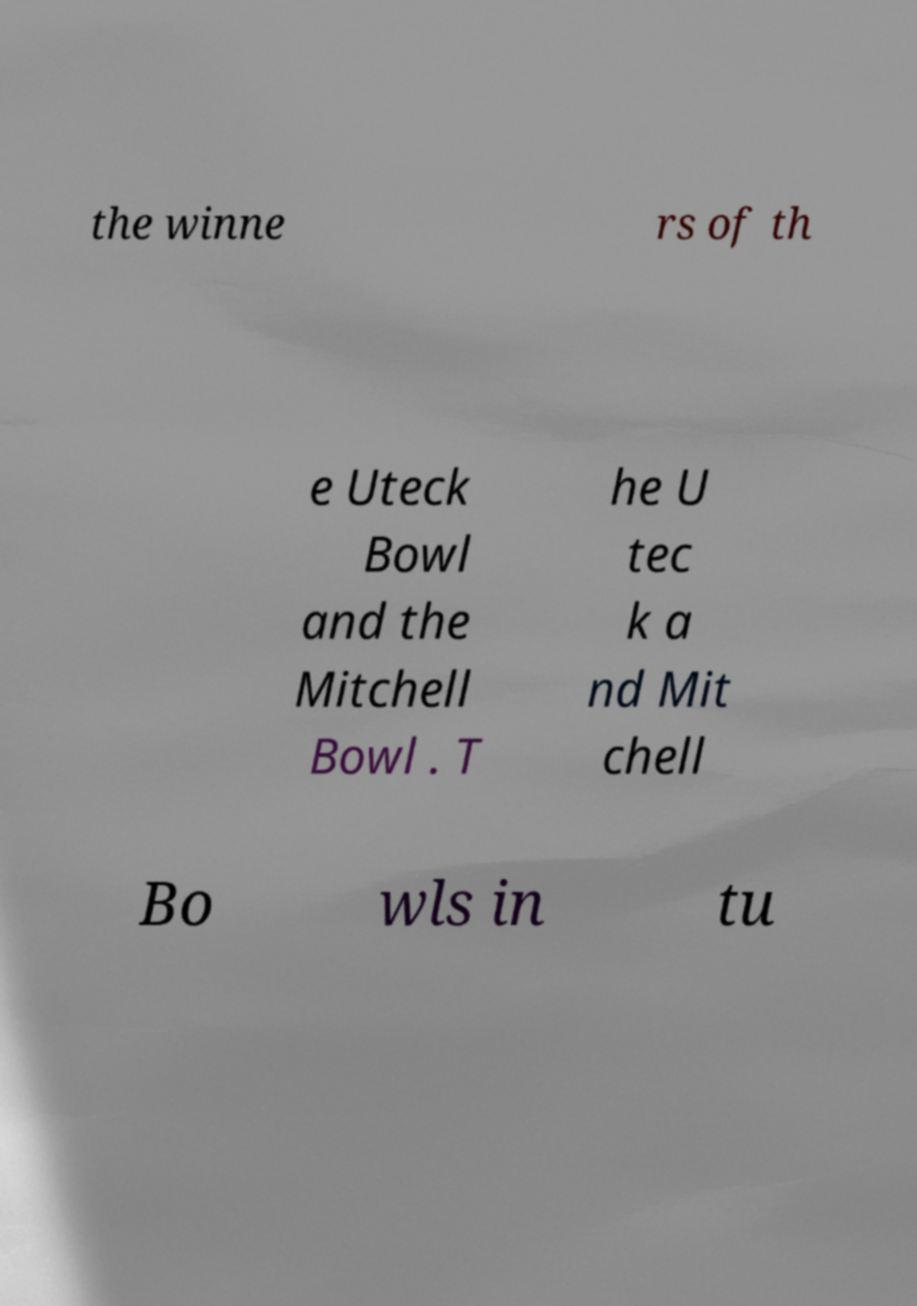Please read and relay the text visible in this image. What does it say? the winne rs of th e Uteck Bowl and the Mitchell Bowl . T he U tec k a nd Mit chell Bo wls in tu 